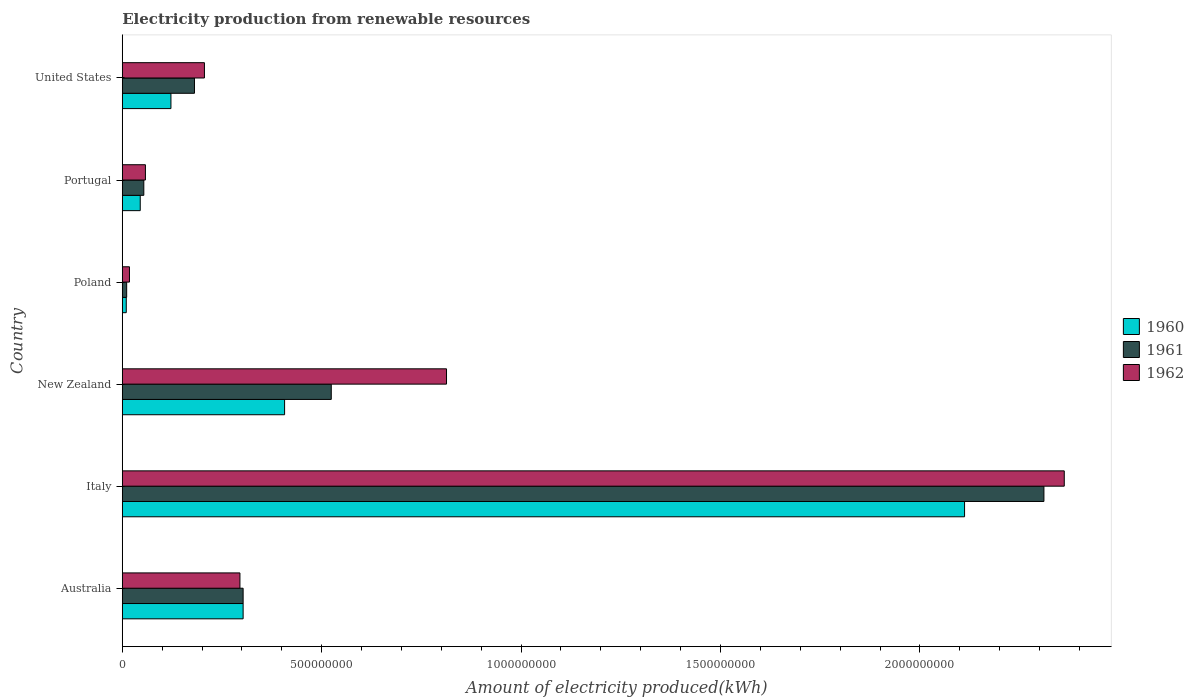How many different coloured bars are there?
Provide a short and direct response. 3. How many groups of bars are there?
Ensure brevity in your answer.  6. What is the label of the 6th group of bars from the top?
Give a very brief answer. Australia. Across all countries, what is the maximum amount of electricity produced in 1961?
Your answer should be compact. 2.31e+09. Across all countries, what is the minimum amount of electricity produced in 1961?
Provide a succinct answer. 1.10e+07. In which country was the amount of electricity produced in 1962 maximum?
Give a very brief answer. Italy. What is the total amount of electricity produced in 1962 in the graph?
Provide a succinct answer. 3.75e+09. What is the difference between the amount of electricity produced in 1962 in Australia and that in Poland?
Give a very brief answer. 2.77e+08. What is the difference between the amount of electricity produced in 1962 in Italy and the amount of electricity produced in 1961 in Australia?
Offer a very short reply. 2.06e+09. What is the average amount of electricity produced in 1960 per country?
Offer a terse response. 5.00e+08. What is the difference between the amount of electricity produced in 1960 and amount of electricity produced in 1961 in New Zealand?
Ensure brevity in your answer.  -1.17e+08. In how many countries, is the amount of electricity produced in 1961 greater than 1000000000 kWh?
Make the answer very short. 1. What is the ratio of the amount of electricity produced in 1960 in Italy to that in Poland?
Ensure brevity in your answer.  211.2. Is the amount of electricity produced in 1962 in Australia less than that in Poland?
Offer a terse response. No. What is the difference between the highest and the second highest amount of electricity produced in 1961?
Provide a succinct answer. 1.79e+09. What is the difference between the highest and the lowest amount of electricity produced in 1961?
Keep it short and to the point. 2.30e+09. In how many countries, is the amount of electricity produced in 1962 greater than the average amount of electricity produced in 1962 taken over all countries?
Offer a very short reply. 2. Are all the bars in the graph horizontal?
Provide a short and direct response. Yes. What is the difference between two consecutive major ticks on the X-axis?
Keep it short and to the point. 5.00e+08. Are the values on the major ticks of X-axis written in scientific E-notation?
Your answer should be compact. No. Does the graph contain grids?
Your response must be concise. No. How many legend labels are there?
Give a very brief answer. 3. How are the legend labels stacked?
Your answer should be very brief. Vertical. What is the title of the graph?
Give a very brief answer. Electricity production from renewable resources. What is the label or title of the X-axis?
Provide a short and direct response. Amount of electricity produced(kWh). What is the label or title of the Y-axis?
Your answer should be compact. Country. What is the Amount of electricity produced(kWh) of 1960 in Australia?
Offer a terse response. 3.03e+08. What is the Amount of electricity produced(kWh) of 1961 in Australia?
Keep it short and to the point. 3.03e+08. What is the Amount of electricity produced(kWh) of 1962 in Australia?
Your answer should be very brief. 2.95e+08. What is the Amount of electricity produced(kWh) in 1960 in Italy?
Give a very brief answer. 2.11e+09. What is the Amount of electricity produced(kWh) in 1961 in Italy?
Keep it short and to the point. 2.31e+09. What is the Amount of electricity produced(kWh) of 1962 in Italy?
Keep it short and to the point. 2.36e+09. What is the Amount of electricity produced(kWh) of 1960 in New Zealand?
Your answer should be very brief. 4.07e+08. What is the Amount of electricity produced(kWh) in 1961 in New Zealand?
Offer a terse response. 5.24e+08. What is the Amount of electricity produced(kWh) in 1962 in New Zealand?
Your response must be concise. 8.13e+08. What is the Amount of electricity produced(kWh) in 1961 in Poland?
Keep it short and to the point. 1.10e+07. What is the Amount of electricity produced(kWh) in 1962 in Poland?
Keep it short and to the point. 1.80e+07. What is the Amount of electricity produced(kWh) of 1960 in Portugal?
Your answer should be compact. 4.50e+07. What is the Amount of electricity produced(kWh) in 1961 in Portugal?
Your answer should be very brief. 5.40e+07. What is the Amount of electricity produced(kWh) in 1962 in Portugal?
Offer a very short reply. 5.80e+07. What is the Amount of electricity produced(kWh) of 1960 in United States?
Your response must be concise. 1.22e+08. What is the Amount of electricity produced(kWh) in 1961 in United States?
Make the answer very short. 1.81e+08. What is the Amount of electricity produced(kWh) of 1962 in United States?
Make the answer very short. 2.06e+08. Across all countries, what is the maximum Amount of electricity produced(kWh) of 1960?
Your answer should be compact. 2.11e+09. Across all countries, what is the maximum Amount of electricity produced(kWh) of 1961?
Provide a short and direct response. 2.31e+09. Across all countries, what is the maximum Amount of electricity produced(kWh) of 1962?
Give a very brief answer. 2.36e+09. Across all countries, what is the minimum Amount of electricity produced(kWh) of 1961?
Make the answer very short. 1.10e+07. Across all countries, what is the minimum Amount of electricity produced(kWh) of 1962?
Your response must be concise. 1.80e+07. What is the total Amount of electricity produced(kWh) in 1960 in the graph?
Make the answer very short. 3.00e+09. What is the total Amount of electricity produced(kWh) in 1961 in the graph?
Your response must be concise. 3.38e+09. What is the total Amount of electricity produced(kWh) of 1962 in the graph?
Give a very brief answer. 3.75e+09. What is the difference between the Amount of electricity produced(kWh) of 1960 in Australia and that in Italy?
Give a very brief answer. -1.81e+09. What is the difference between the Amount of electricity produced(kWh) in 1961 in Australia and that in Italy?
Provide a short and direct response. -2.01e+09. What is the difference between the Amount of electricity produced(kWh) of 1962 in Australia and that in Italy?
Your response must be concise. -2.07e+09. What is the difference between the Amount of electricity produced(kWh) in 1960 in Australia and that in New Zealand?
Offer a terse response. -1.04e+08. What is the difference between the Amount of electricity produced(kWh) in 1961 in Australia and that in New Zealand?
Provide a succinct answer. -2.21e+08. What is the difference between the Amount of electricity produced(kWh) in 1962 in Australia and that in New Zealand?
Provide a succinct answer. -5.18e+08. What is the difference between the Amount of electricity produced(kWh) in 1960 in Australia and that in Poland?
Offer a terse response. 2.93e+08. What is the difference between the Amount of electricity produced(kWh) of 1961 in Australia and that in Poland?
Make the answer very short. 2.92e+08. What is the difference between the Amount of electricity produced(kWh) in 1962 in Australia and that in Poland?
Give a very brief answer. 2.77e+08. What is the difference between the Amount of electricity produced(kWh) of 1960 in Australia and that in Portugal?
Your answer should be very brief. 2.58e+08. What is the difference between the Amount of electricity produced(kWh) in 1961 in Australia and that in Portugal?
Offer a terse response. 2.49e+08. What is the difference between the Amount of electricity produced(kWh) of 1962 in Australia and that in Portugal?
Your answer should be compact. 2.37e+08. What is the difference between the Amount of electricity produced(kWh) of 1960 in Australia and that in United States?
Your answer should be very brief. 1.81e+08. What is the difference between the Amount of electricity produced(kWh) of 1961 in Australia and that in United States?
Keep it short and to the point. 1.22e+08. What is the difference between the Amount of electricity produced(kWh) of 1962 in Australia and that in United States?
Make the answer very short. 8.90e+07. What is the difference between the Amount of electricity produced(kWh) in 1960 in Italy and that in New Zealand?
Your answer should be compact. 1.70e+09. What is the difference between the Amount of electricity produced(kWh) in 1961 in Italy and that in New Zealand?
Offer a very short reply. 1.79e+09. What is the difference between the Amount of electricity produced(kWh) of 1962 in Italy and that in New Zealand?
Offer a very short reply. 1.55e+09. What is the difference between the Amount of electricity produced(kWh) in 1960 in Italy and that in Poland?
Make the answer very short. 2.10e+09. What is the difference between the Amount of electricity produced(kWh) in 1961 in Italy and that in Poland?
Give a very brief answer. 2.30e+09. What is the difference between the Amount of electricity produced(kWh) in 1962 in Italy and that in Poland?
Ensure brevity in your answer.  2.34e+09. What is the difference between the Amount of electricity produced(kWh) of 1960 in Italy and that in Portugal?
Your response must be concise. 2.07e+09. What is the difference between the Amount of electricity produced(kWh) of 1961 in Italy and that in Portugal?
Offer a terse response. 2.26e+09. What is the difference between the Amount of electricity produced(kWh) in 1962 in Italy and that in Portugal?
Provide a short and direct response. 2.30e+09. What is the difference between the Amount of electricity produced(kWh) of 1960 in Italy and that in United States?
Your answer should be compact. 1.99e+09. What is the difference between the Amount of electricity produced(kWh) in 1961 in Italy and that in United States?
Provide a succinct answer. 2.13e+09. What is the difference between the Amount of electricity produced(kWh) of 1962 in Italy and that in United States?
Offer a very short reply. 2.16e+09. What is the difference between the Amount of electricity produced(kWh) of 1960 in New Zealand and that in Poland?
Keep it short and to the point. 3.97e+08. What is the difference between the Amount of electricity produced(kWh) in 1961 in New Zealand and that in Poland?
Offer a very short reply. 5.13e+08. What is the difference between the Amount of electricity produced(kWh) of 1962 in New Zealand and that in Poland?
Make the answer very short. 7.95e+08. What is the difference between the Amount of electricity produced(kWh) in 1960 in New Zealand and that in Portugal?
Offer a terse response. 3.62e+08. What is the difference between the Amount of electricity produced(kWh) of 1961 in New Zealand and that in Portugal?
Offer a terse response. 4.70e+08. What is the difference between the Amount of electricity produced(kWh) in 1962 in New Zealand and that in Portugal?
Offer a terse response. 7.55e+08. What is the difference between the Amount of electricity produced(kWh) of 1960 in New Zealand and that in United States?
Ensure brevity in your answer.  2.85e+08. What is the difference between the Amount of electricity produced(kWh) in 1961 in New Zealand and that in United States?
Ensure brevity in your answer.  3.43e+08. What is the difference between the Amount of electricity produced(kWh) of 1962 in New Zealand and that in United States?
Offer a very short reply. 6.07e+08. What is the difference between the Amount of electricity produced(kWh) of 1960 in Poland and that in Portugal?
Ensure brevity in your answer.  -3.50e+07. What is the difference between the Amount of electricity produced(kWh) in 1961 in Poland and that in Portugal?
Offer a very short reply. -4.30e+07. What is the difference between the Amount of electricity produced(kWh) in 1962 in Poland and that in Portugal?
Provide a short and direct response. -4.00e+07. What is the difference between the Amount of electricity produced(kWh) of 1960 in Poland and that in United States?
Offer a terse response. -1.12e+08. What is the difference between the Amount of electricity produced(kWh) in 1961 in Poland and that in United States?
Provide a short and direct response. -1.70e+08. What is the difference between the Amount of electricity produced(kWh) in 1962 in Poland and that in United States?
Make the answer very short. -1.88e+08. What is the difference between the Amount of electricity produced(kWh) in 1960 in Portugal and that in United States?
Offer a very short reply. -7.70e+07. What is the difference between the Amount of electricity produced(kWh) in 1961 in Portugal and that in United States?
Offer a very short reply. -1.27e+08. What is the difference between the Amount of electricity produced(kWh) of 1962 in Portugal and that in United States?
Offer a terse response. -1.48e+08. What is the difference between the Amount of electricity produced(kWh) in 1960 in Australia and the Amount of electricity produced(kWh) in 1961 in Italy?
Keep it short and to the point. -2.01e+09. What is the difference between the Amount of electricity produced(kWh) of 1960 in Australia and the Amount of electricity produced(kWh) of 1962 in Italy?
Your answer should be compact. -2.06e+09. What is the difference between the Amount of electricity produced(kWh) of 1961 in Australia and the Amount of electricity produced(kWh) of 1962 in Italy?
Provide a succinct answer. -2.06e+09. What is the difference between the Amount of electricity produced(kWh) in 1960 in Australia and the Amount of electricity produced(kWh) in 1961 in New Zealand?
Keep it short and to the point. -2.21e+08. What is the difference between the Amount of electricity produced(kWh) of 1960 in Australia and the Amount of electricity produced(kWh) of 1962 in New Zealand?
Ensure brevity in your answer.  -5.10e+08. What is the difference between the Amount of electricity produced(kWh) of 1961 in Australia and the Amount of electricity produced(kWh) of 1962 in New Zealand?
Your answer should be compact. -5.10e+08. What is the difference between the Amount of electricity produced(kWh) in 1960 in Australia and the Amount of electricity produced(kWh) in 1961 in Poland?
Offer a very short reply. 2.92e+08. What is the difference between the Amount of electricity produced(kWh) in 1960 in Australia and the Amount of electricity produced(kWh) in 1962 in Poland?
Provide a succinct answer. 2.85e+08. What is the difference between the Amount of electricity produced(kWh) of 1961 in Australia and the Amount of electricity produced(kWh) of 1962 in Poland?
Offer a terse response. 2.85e+08. What is the difference between the Amount of electricity produced(kWh) in 1960 in Australia and the Amount of electricity produced(kWh) in 1961 in Portugal?
Make the answer very short. 2.49e+08. What is the difference between the Amount of electricity produced(kWh) of 1960 in Australia and the Amount of electricity produced(kWh) of 1962 in Portugal?
Make the answer very short. 2.45e+08. What is the difference between the Amount of electricity produced(kWh) in 1961 in Australia and the Amount of electricity produced(kWh) in 1962 in Portugal?
Give a very brief answer. 2.45e+08. What is the difference between the Amount of electricity produced(kWh) of 1960 in Australia and the Amount of electricity produced(kWh) of 1961 in United States?
Make the answer very short. 1.22e+08. What is the difference between the Amount of electricity produced(kWh) of 1960 in Australia and the Amount of electricity produced(kWh) of 1962 in United States?
Give a very brief answer. 9.70e+07. What is the difference between the Amount of electricity produced(kWh) in 1961 in Australia and the Amount of electricity produced(kWh) in 1962 in United States?
Make the answer very short. 9.70e+07. What is the difference between the Amount of electricity produced(kWh) in 1960 in Italy and the Amount of electricity produced(kWh) in 1961 in New Zealand?
Your answer should be compact. 1.59e+09. What is the difference between the Amount of electricity produced(kWh) of 1960 in Italy and the Amount of electricity produced(kWh) of 1962 in New Zealand?
Provide a succinct answer. 1.30e+09. What is the difference between the Amount of electricity produced(kWh) in 1961 in Italy and the Amount of electricity produced(kWh) in 1962 in New Zealand?
Provide a succinct answer. 1.50e+09. What is the difference between the Amount of electricity produced(kWh) in 1960 in Italy and the Amount of electricity produced(kWh) in 1961 in Poland?
Give a very brief answer. 2.10e+09. What is the difference between the Amount of electricity produced(kWh) in 1960 in Italy and the Amount of electricity produced(kWh) in 1962 in Poland?
Your answer should be compact. 2.09e+09. What is the difference between the Amount of electricity produced(kWh) in 1961 in Italy and the Amount of electricity produced(kWh) in 1962 in Poland?
Provide a short and direct response. 2.29e+09. What is the difference between the Amount of electricity produced(kWh) of 1960 in Italy and the Amount of electricity produced(kWh) of 1961 in Portugal?
Your answer should be very brief. 2.06e+09. What is the difference between the Amount of electricity produced(kWh) in 1960 in Italy and the Amount of electricity produced(kWh) in 1962 in Portugal?
Make the answer very short. 2.05e+09. What is the difference between the Amount of electricity produced(kWh) of 1961 in Italy and the Amount of electricity produced(kWh) of 1962 in Portugal?
Ensure brevity in your answer.  2.25e+09. What is the difference between the Amount of electricity produced(kWh) in 1960 in Italy and the Amount of electricity produced(kWh) in 1961 in United States?
Ensure brevity in your answer.  1.93e+09. What is the difference between the Amount of electricity produced(kWh) in 1960 in Italy and the Amount of electricity produced(kWh) in 1962 in United States?
Provide a short and direct response. 1.91e+09. What is the difference between the Amount of electricity produced(kWh) of 1961 in Italy and the Amount of electricity produced(kWh) of 1962 in United States?
Offer a terse response. 2.10e+09. What is the difference between the Amount of electricity produced(kWh) of 1960 in New Zealand and the Amount of electricity produced(kWh) of 1961 in Poland?
Give a very brief answer. 3.96e+08. What is the difference between the Amount of electricity produced(kWh) in 1960 in New Zealand and the Amount of electricity produced(kWh) in 1962 in Poland?
Your answer should be very brief. 3.89e+08. What is the difference between the Amount of electricity produced(kWh) of 1961 in New Zealand and the Amount of electricity produced(kWh) of 1962 in Poland?
Make the answer very short. 5.06e+08. What is the difference between the Amount of electricity produced(kWh) in 1960 in New Zealand and the Amount of electricity produced(kWh) in 1961 in Portugal?
Your answer should be very brief. 3.53e+08. What is the difference between the Amount of electricity produced(kWh) of 1960 in New Zealand and the Amount of electricity produced(kWh) of 1962 in Portugal?
Provide a short and direct response. 3.49e+08. What is the difference between the Amount of electricity produced(kWh) in 1961 in New Zealand and the Amount of electricity produced(kWh) in 1962 in Portugal?
Ensure brevity in your answer.  4.66e+08. What is the difference between the Amount of electricity produced(kWh) of 1960 in New Zealand and the Amount of electricity produced(kWh) of 1961 in United States?
Offer a very short reply. 2.26e+08. What is the difference between the Amount of electricity produced(kWh) in 1960 in New Zealand and the Amount of electricity produced(kWh) in 1962 in United States?
Ensure brevity in your answer.  2.01e+08. What is the difference between the Amount of electricity produced(kWh) of 1961 in New Zealand and the Amount of electricity produced(kWh) of 1962 in United States?
Keep it short and to the point. 3.18e+08. What is the difference between the Amount of electricity produced(kWh) in 1960 in Poland and the Amount of electricity produced(kWh) in 1961 in Portugal?
Your answer should be compact. -4.40e+07. What is the difference between the Amount of electricity produced(kWh) of 1960 in Poland and the Amount of electricity produced(kWh) of 1962 in Portugal?
Give a very brief answer. -4.80e+07. What is the difference between the Amount of electricity produced(kWh) of 1961 in Poland and the Amount of electricity produced(kWh) of 1962 in Portugal?
Your answer should be compact. -4.70e+07. What is the difference between the Amount of electricity produced(kWh) of 1960 in Poland and the Amount of electricity produced(kWh) of 1961 in United States?
Your answer should be compact. -1.71e+08. What is the difference between the Amount of electricity produced(kWh) in 1960 in Poland and the Amount of electricity produced(kWh) in 1962 in United States?
Give a very brief answer. -1.96e+08. What is the difference between the Amount of electricity produced(kWh) in 1961 in Poland and the Amount of electricity produced(kWh) in 1962 in United States?
Your answer should be compact. -1.95e+08. What is the difference between the Amount of electricity produced(kWh) of 1960 in Portugal and the Amount of electricity produced(kWh) of 1961 in United States?
Provide a succinct answer. -1.36e+08. What is the difference between the Amount of electricity produced(kWh) in 1960 in Portugal and the Amount of electricity produced(kWh) in 1962 in United States?
Offer a terse response. -1.61e+08. What is the difference between the Amount of electricity produced(kWh) in 1961 in Portugal and the Amount of electricity produced(kWh) in 1962 in United States?
Your answer should be compact. -1.52e+08. What is the average Amount of electricity produced(kWh) of 1960 per country?
Offer a very short reply. 5.00e+08. What is the average Amount of electricity produced(kWh) of 1961 per country?
Your answer should be very brief. 5.64e+08. What is the average Amount of electricity produced(kWh) of 1962 per country?
Offer a terse response. 6.25e+08. What is the difference between the Amount of electricity produced(kWh) in 1960 and Amount of electricity produced(kWh) in 1961 in Australia?
Give a very brief answer. 0. What is the difference between the Amount of electricity produced(kWh) of 1960 and Amount of electricity produced(kWh) of 1962 in Australia?
Give a very brief answer. 8.00e+06. What is the difference between the Amount of electricity produced(kWh) in 1961 and Amount of electricity produced(kWh) in 1962 in Australia?
Your answer should be very brief. 8.00e+06. What is the difference between the Amount of electricity produced(kWh) of 1960 and Amount of electricity produced(kWh) of 1961 in Italy?
Provide a succinct answer. -1.99e+08. What is the difference between the Amount of electricity produced(kWh) of 1960 and Amount of electricity produced(kWh) of 1962 in Italy?
Give a very brief answer. -2.50e+08. What is the difference between the Amount of electricity produced(kWh) of 1961 and Amount of electricity produced(kWh) of 1962 in Italy?
Give a very brief answer. -5.10e+07. What is the difference between the Amount of electricity produced(kWh) in 1960 and Amount of electricity produced(kWh) in 1961 in New Zealand?
Ensure brevity in your answer.  -1.17e+08. What is the difference between the Amount of electricity produced(kWh) in 1960 and Amount of electricity produced(kWh) in 1962 in New Zealand?
Provide a succinct answer. -4.06e+08. What is the difference between the Amount of electricity produced(kWh) of 1961 and Amount of electricity produced(kWh) of 1962 in New Zealand?
Your answer should be very brief. -2.89e+08. What is the difference between the Amount of electricity produced(kWh) in 1960 and Amount of electricity produced(kWh) in 1962 in Poland?
Your response must be concise. -8.00e+06. What is the difference between the Amount of electricity produced(kWh) of 1961 and Amount of electricity produced(kWh) of 1962 in Poland?
Offer a very short reply. -7.00e+06. What is the difference between the Amount of electricity produced(kWh) in 1960 and Amount of electricity produced(kWh) in 1961 in Portugal?
Offer a very short reply. -9.00e+06. What is the difference between the Amount of electricity produced(kWh) in 1960 and Amount of electricity produced(kWh) in 1962 in Portugal?
Offer a very short reply. -1.30e+07. What is the difference between the Amount of electricity produced(kWh) in 1961 and Amount of electricity produced(kWh) in 1962 in Portugal?
Your response must be concise. -4.00e+06. What is the difference between the Amount of electricity produced(kWh) in 1960 and Amount of electricity produced(kWh) in 1961 in United States?
Your answer should be very brief. -5.90e+07. What is the difference between the Amount of electricity produced(kWh) of 1960 and Amount of electricity produced(kWh) of 1962 in United States?
Your response must be concise. -8.40e+07. What is the difference between the Amount of electricity produced(kWh) in 1961 and Amount of electricity produced(kWh) in 1962 in United States?
Your response must be concise. -2.50e+07. What is the ratio of the Amount of electricity produced(kWh) of 1960 in Australia to that in Italy?
Give a very brief answer. 0.14. What is the ratio of the Amount of electricity produced(kWh) of 1961 in Australia to that in Italy?
Give a very brief answer. 0.13. What is the ratio of the Amount of electricity produced(kWh) of 1962 in Australia to that in Italy?
Keep it short and to the point. 0.12. What is the ratio of the Amount of electricity produced(kWh) of 1960 in Australia to that in New Zealand?
Your answer should be very brief. 0.74. What is the ratio of the Amount of electricity produced(kWh) of 1961 in Australia to that in New Zealand?
Your answer should be very brief. 0.58. What is the ratio of the Amount of electricity produced(kWh) in 1962 in Australia to that in New Zealand?
Offer a terse response. 0.36. What is the ratio of the Amount of electricity produced(kWh) in 1960 in Australia to that in Poland?
Offer a very short reply. 30.3. What is the ratio of the Amount of electricity produced(kWh) in 1961 in Australia to that in Poland?
Provide a succinct answer. 27.55. What is the ratio of the Amount of electricity produced(kWh) of 1962 in Australia to that in Poland?
Ensure brevity in your answer.  16.39. What is the ratio of the Amount of electricity produced(kWh) of 1960 in Australia to that in Portugal?
Your answer should be compact. 6.73. What is the ratio of the Amount of electricity produced(kWh) in 1961 in Australia to that in Portugal?
Offer a very short reply. 5.61. What is the ratio of the Amount of electricity produced(kWh) in 1962 in Australia to that in Portugal?
Your answer should be very brief. 5.09. What is the ratio of the Amount of electricity produced(kWh) in 1960 in Australia to that in United States?
Your answer should be compact. 2.48. What is the ratio of the Amount of electricity produced(kWh) in 1961 in Australia to that in United States?
Offer a very short reply. 1.67. What is the ratio of the Amount of electricity produced(kWh) in 1962 in Australia to that in United States?
Your answer should be very brief. 1.43. What is the ratio of the Amount of electricity produced(kWh) of 1960 in Italy to that in New Zealand?
Make the answer very short. 5.19. What is the ratio of the Amount of electricity produced(kWh) in 1961 in Italy to that in New Zealand?
Ensure brevity in your answer.  4.41. What is the ratio of the Amount of electricity produced(kWh) in 1962 in Italy to that in New Zealand?
Ensure brevity in your answer.  2.91. What is the ratio of the Amount of electricity produced(kWh) of 1960 in Italy to that in Poland?
Give a very brief answer. 211.2. What is the ratio of the Amount of electricity produced(kWh) in 1961 in Italy to that in Poland?
Keep it short and to the point. 210.09. What is the ratio of the Amount of electricity produced(kWh) in 1962 in Italy to that in Poland?
Ensure brevity in your answer.  131.22. What is the ratio of the Amount of electricity produced(kWh) of 1960 in Italy to that in Portugal?
Make the answer very short. 46.93. What is the ratio of the Amount of electricity produced(kWh) in 1961 in Italy to that in Portugal?
Your answer should be very brief. 42.8. What is the ratio of the Amount of electricity produced(kWh) in 1962 in Italy to that in Portugal?
Your response must be concise. 40.72. What is the ratio of the Amount of electricity produced(kWh) of 1960 in Italy to that in United States?
Make the answer very short. 17.31. What is the ratio of the Amount of electricity produced(kWh) of 1961 in Italy to that in United States?
Offer a very short reply. 12.77. What is the ratio of the Amount of electricity produced(kWh) of 1962 in Italy to that in United States?
Ensure brevity in your answer.  11.47. What is the ratio of the Amount of electricity produced(kWh) in 1960 in New Zealand to that in Poland?
Ensure brevity in your answer.  40.7. What is the ratio of the Amount of electricity produced(kWh) of 1961 in New Zealand to that in Poland?
Provide a succinct answer. 47.64. What is the ratio of the Amount of electricity produced(kWh) in 1962 in New Zealand to that in Poland?
Your response must be concise. 45.17. What is the ratio of the Amount of electricity produced(kWh) in 1960 in New Zealand to that in Portugal?
Your answer should be very brief. 9.04. What is the ratio of the Amount of electricity produced(kWh) in 1961 in New Zealand to that in Portugal?
Make the answer very short. 9.7. What is the ratio of the Amount of electricity produced(kWh) of 1962 in New Zealand to that in Portugal?
Your answer should be compact. 14.02. What is the ratio of the Amount of electricity produced(kWh) in 1960 in New Zealand to that in United States?
Keep it short and to the point. 3.34. What is the ratio of the Amount of electricity produced(kWh) in 1961 in New Zealand to that in United States?
Make the answer very short. 2.9. What is the ratio of the Amount of electricity produced(kWh) in 1962 in New Zealand to that in United States?
Your answer should be very brief. 3.95. What is the ratio of the Amount of electricity produced(kWh) in 1960 in Poland to that in Portugal?
Offer a terse response. 0.22. What is the ratio of the Amount of electricity produced(kWh) in 1961 in Poland to that in Portugal?
Make the answer very short. 0.2. What is the ratio of the Amount of electricity produced(kWh) in 1962 in Poland to that in Portugal?
Keep it short and to the point. 0.31. What is the ratio of the Amount of electricity produced(kWh) in 1960 in Poland to that in United States?
Your response must be concise. 0.08. What is the ratio of the Amount of electricity produced(kWh) in 1961 in Poland to that in United States?
Provide a short and direct response. 0.06. What is the ratio of the Amount of electricity produced(kWh) of 1962 in Poland to that in United States?
Provide a succinct answer. 0.09. What is the ratio of the Amount of electricity produced(kWh) of 1960 in Portugal to that in United States?
Keep it short and to the point. 0.37. What is the ratio of the Amount of electricity produced(kWh) of 1961 in Portugal to that in United States?
Give a very brief answer. 0.3. What is the ratio of the Amount of electricity produced(kWh) in 1962 in Portugal to that in United States?
Offer a very short reply. 0.28. What is the difference between the highest and the second highest Amount of electricity produced(kWh) of 1960?
Give a very brief answer. 1.70e+09. What is the difference between the highest and the second highest Amount of electricity produced(kWh) in 1961?
Make the answer very short. 1.79e+09. What is the difference between the highest and the second highest Amount of electricity produced(kWh) of 1962?
Your answer should be compact. 1.55e+09. What is the difference between the highest and the lowest Amount of electricity produced(kWh) of 1960?
Ensure brevity in your answer.  2.10e+09. What is the difference between the highest and the lowest Amount of electricity produced(kWh) of 1961?
Offer a very short reply. 2.30e+09. What is the difference between the highest and the lowest Amount of electricity produced(kWh) of 1962?
Keep it short and to the point. 2.34e+09. 